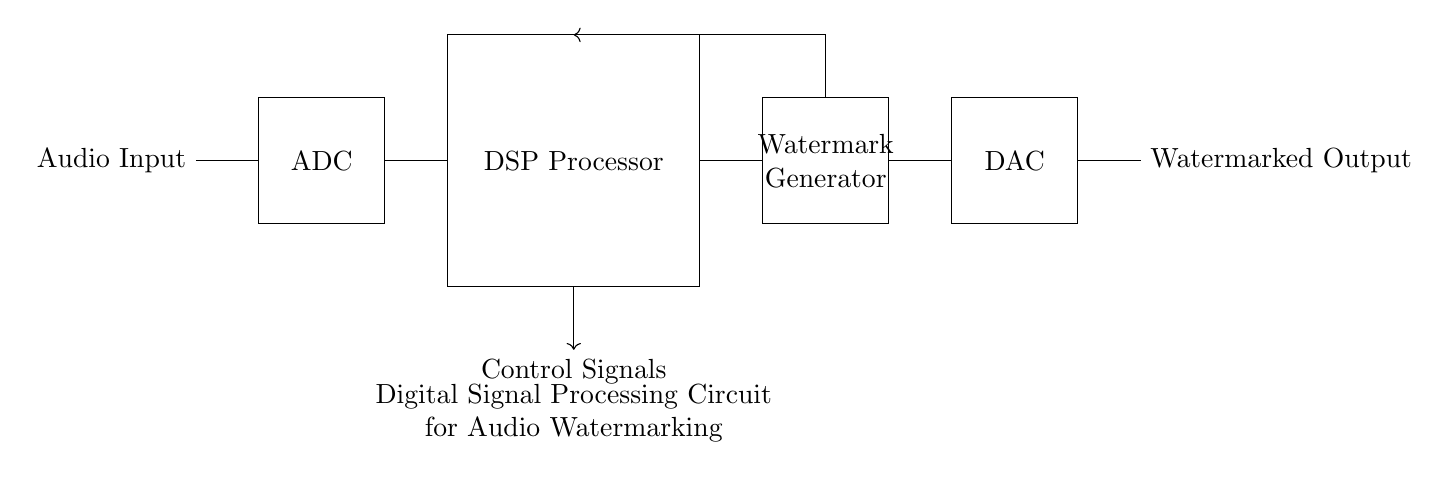What is the first component in the circuit? The first component is labeled as "Audio Input," which indicates it receives audio signals.
Answer: Audio Input What follows the ADC in the circuit? The component that follows the ADC is the DSP Processor, which is responsible for processing the audio signals.
Answer: DSP Processor How many components are there in total? Counting the components listed, there are five main components: Audio Input, ADC, DSP Processor, Watermark Generator, and DAC.
Answer: Five What purpose does the Watermark Generator serve? The Watermark Generator is responsible for embedding a watermark into the audio signal, enabling tracking.
Answer: Watermark What type of circuit is depicted here? The circuit is a digital signal processing circuit specifically designed for embedding audio watermarks.
Answer: Digital Signal Processing Circuit What is being outputted at the end of the circuit? The output at the end of the circuit is a Watermarked Output, indicating the audio signal has been processed with the watermark.
Answer: Watermarked Output What kind of signals are indicated as being controlled in the circuit? Control Signals are indicated as being managed within the circuit to oversee the processing stages.
Answer: Control Signals 